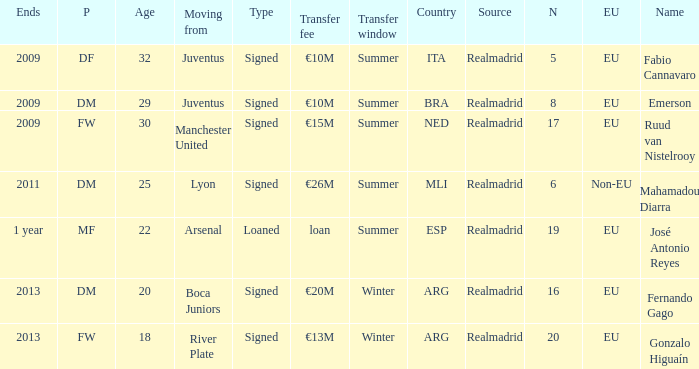What is the EU status of ESP? EU. 